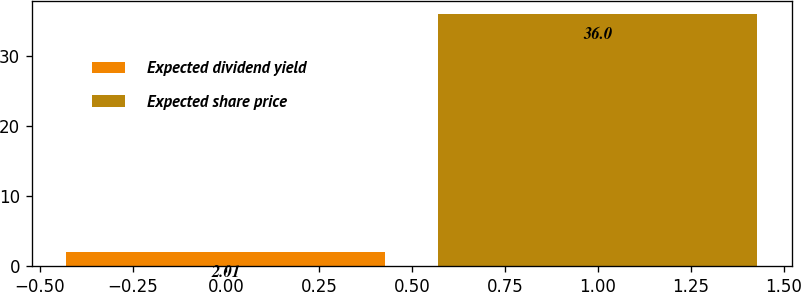Convert chart to OTSL. <chart><loc_0><loc_0><loc_500><loc_500><bar_chart><fcel>Expected dividend yield<fcel>Expected share price<nl><fcel>2.01<fcel>36<nl></chart> 